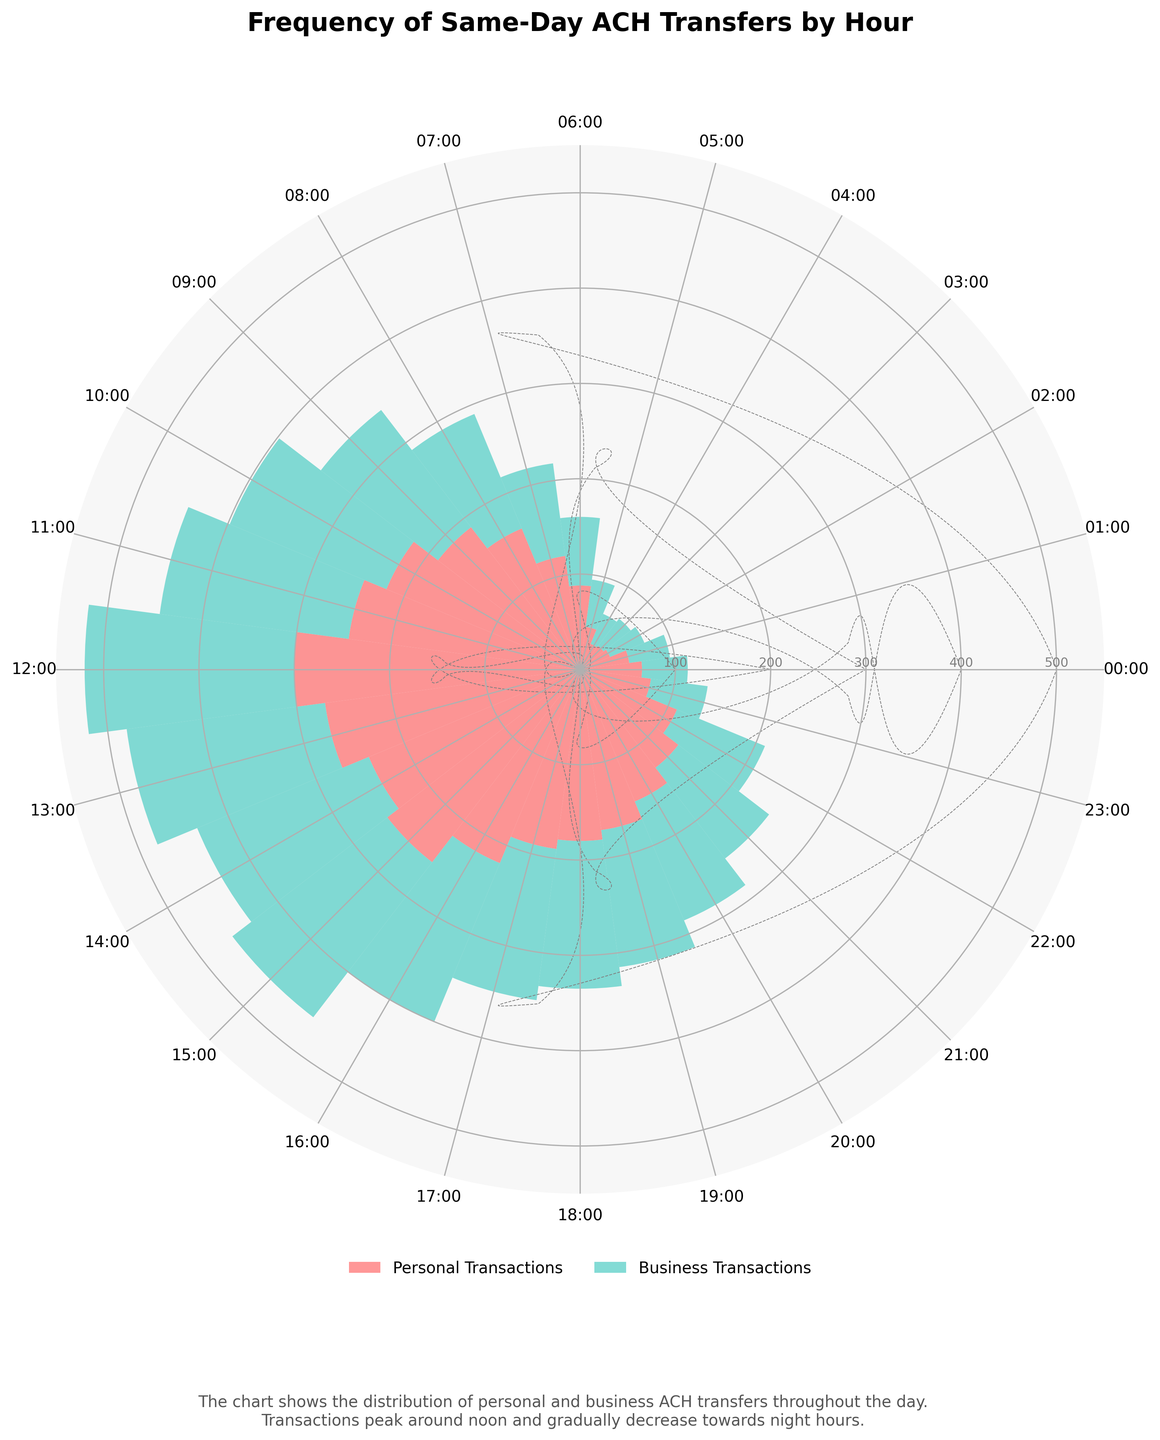What's the title of the chart? The title is located at the top of the chart. It summarizes the purpose of the chart.
Answer: Frequency of Same-Day ACH Transfers by Hour At what hour do personal transactions peak? Find the hour with the highest bar for personal transactions (pink/red color).
Answer: 12:00 (noon) How many business transactions occur at 10:00? Look at the height of the green/blue bar segment at the 10:00 position.
Answer: 178 Which hour has the least number of total transactions? Add the personal and business transactions for each hour and identify the smallest sum.
Answer: 04:00 (63 total transactions) Are personal transactions more frequent than business transactions at 05:00? Compare the height of the pink/red bar segment with the green/blue bar segment at 05:00.
Answer: No What is the range of total transactions between 08:00 and 17:00? Calculate the difference between the highest and lowest number of total transactions between 08:00 and 17:00 hours.
Answer: 100 (300 at 12:00 - 200 at 08:00) During which hour are business transactions the highest? Identify the hour with the highest green/blue bar segment.
Answer: 12:00 (noon) How do total transactions at 14:00 compare to those at 07:00? Sum the personal and business transactions for 14:00 and 07:00, then compare.
Answer: Higher at 14:00 What's the combined number of personal and business transactions at 16:00? Sum the personal and business transactions at 16:00.
Answer: 400 Is the trend for both personal and business transactions increasing, decreasing, or mixed from 00:00 to 12:00? Observe the pattern of the bar heights for both personal and business segments from 00:00 to 12:00.
Answer: Increasing 